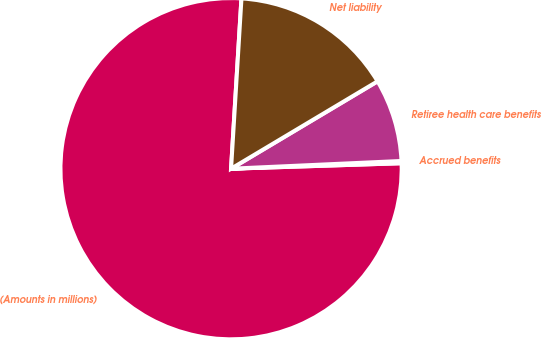Convert chart. <chart><loc_0><loc_0><loc_500><loc_500><pie_chart><fcel>(Amounts in millions)<fcel>Accrued benefits<fcel>Retiree health care benefits<fcel>Net liability<nl><fcel>76.49%<fcel>0.21%<fcel>7.84%<fcel>15.47%<nl></chart> 